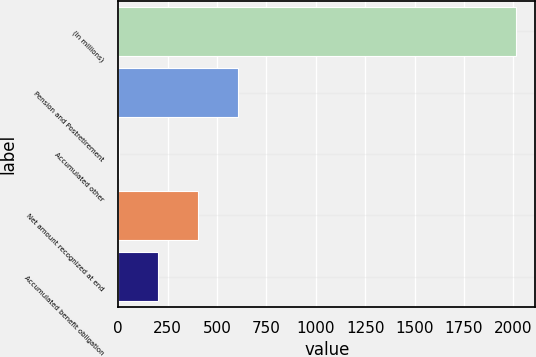<chart> <loc_0><loc_0><loc_500><loc_500><bar_chart><fcel>(In millions)<fcel>Pension and Postretirement<fcel>Accumulated other<fcel>Net amount recognized at end<fcel>Accumulated benefit obligation<nl><fcel>2011<fcel>605.54<fcel>3.2<fcel>404.76<fcel>203.98<nl></chart> 